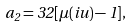<formula> <loc_0><loc_0><loc_500><loc_500>a _ { 2 } = 3 2 [ \mu ( i u ) - 1 ] ,</formula> 